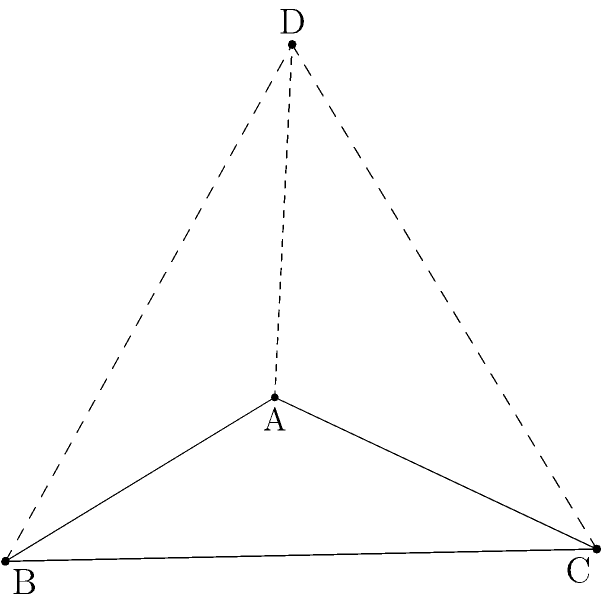As a college counselor specializing in STEM education, you're preparing a workshop on advanced geometry for high school students interested in engineering. You want to challenge them with a problem involving a regular tetrahedron. What is the angle between two adjacent faces of a regular tetrahedron? Let's approach this step-by-step:

1) In a regular tetrahedron, all faces are congruent equilateral triangles.

2) The angle between two adjacent faces is the dihedral angle of the tetrahedron.

3) To find this angle, we can use the following formula:
   $$\cos \theta = \frac{\vec{n_1} \cdot \vec{n_2}}{|\vec{n_1}||\vec{n_2}|}$$
   where $\vec{n_1}$ and $\vec{n_2}$ are normal vectors to the two adjacent faces.

4) For a regular tetrahedron with side length $a$, we can choose a convenient coordinate system:
   A: $(0,0,0)$
   B: $(a,0,0)$
   C: $(\frac{a}{2},\frac{a\sqrt{3}}{2},0)$
   D: $(\frac{a}{2},\frac{a}{2\sqrt{3}},\frac{a\sqrt{2}}{\sqrt{3}})$

5) The normal vector to face ABC is $(0,0,-1)$.

6) The normal vector to face ACD can be found by the cross product of $\vec{AC}$ and $\vec{AD}$:
   $\vec{AC} = (\frac{a}{2},\frac{a\sqrt{3}}{2},0)$
   $\vec{AD} = (\frac{a}{2},\frac{a}{2\sqrt{3}},\frac{a\sqrt{2}}{\sqrt{3}})$
   $\vec{n_2} = \vec{AC} \times \vec{AD} = (\frac{a^2\sqrt{2}}{2\sqrt{3}},-\frac{a^2\sqrt{2}}{4},-\frac{a^2\sqrt{3}}{4})$

7) Normalizing $\vec{n_2}$:
   $\vec{n_2} = (\frac{\sqrt{2}}{\sqrt{3}},-\frac{1}{\sqrt{3}},-\frac{1}{\sqrt{2}})$

8) Now, let's apply the formula:
   $$\cos \theta = (0,0,-1) \cdot (\frac{\sqrt{2}}{\sqrt{3}},-\frac{1}{\sqrt{3}},-\frac{1}{\sqrt{2}}) = \frac{1}{\sqrt{2}}$$

9) Therefore:
   $$\theta = \arccos(\frac{1}{\sqrt{2}}) \approx 70.53°$$
Answer: $\arccos(\frac{1}{\sqrt{2}})$ or approximately 70.53° 